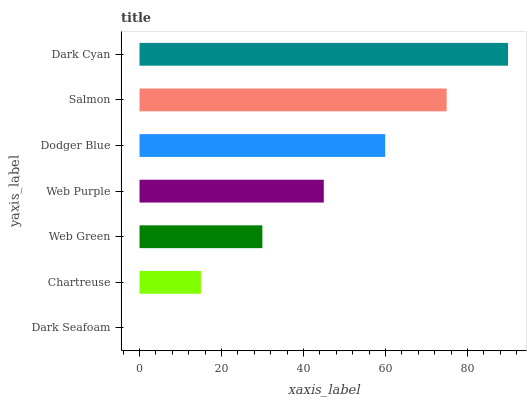Is Dark Seafoam the minimum?
Answer yes or no. Yes. Is Dark Cyan the maximum?
Answer yes or no. Yes. Is Chartreuse the minimum?
Answer yes or no. No. Is Chartreuse the maximum?
Answer yes or no. No. Is Chartreuse greater than Dark Seafoam?
Answer yes or no. Yes. Is Dark Seafoam less than Chartreuse?
Answer yes or no. Yes. Is Dark Seafoam greater than Chartreuse?
Answer yes or no. No. Is Chartreuse less than Dark Seafoam?
Answer yes or no. No. Is Web Purple the high median?
Answer yes or no. Yes. Is Web Purple the low median?
Answer yes or no. Yes. Is Salmon the high median?
Answer yes or no. No. Is Dark Cyan the low median?
Answer yes or no. No. 